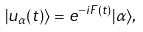Convert formula to latex. <formula><loc_0><loc_0><loc_500><loc_500>| u _ { \alpha } ( t ) \rangle = e ^ { - i F ( t ) } | \alpha \rangle ,</formula> 